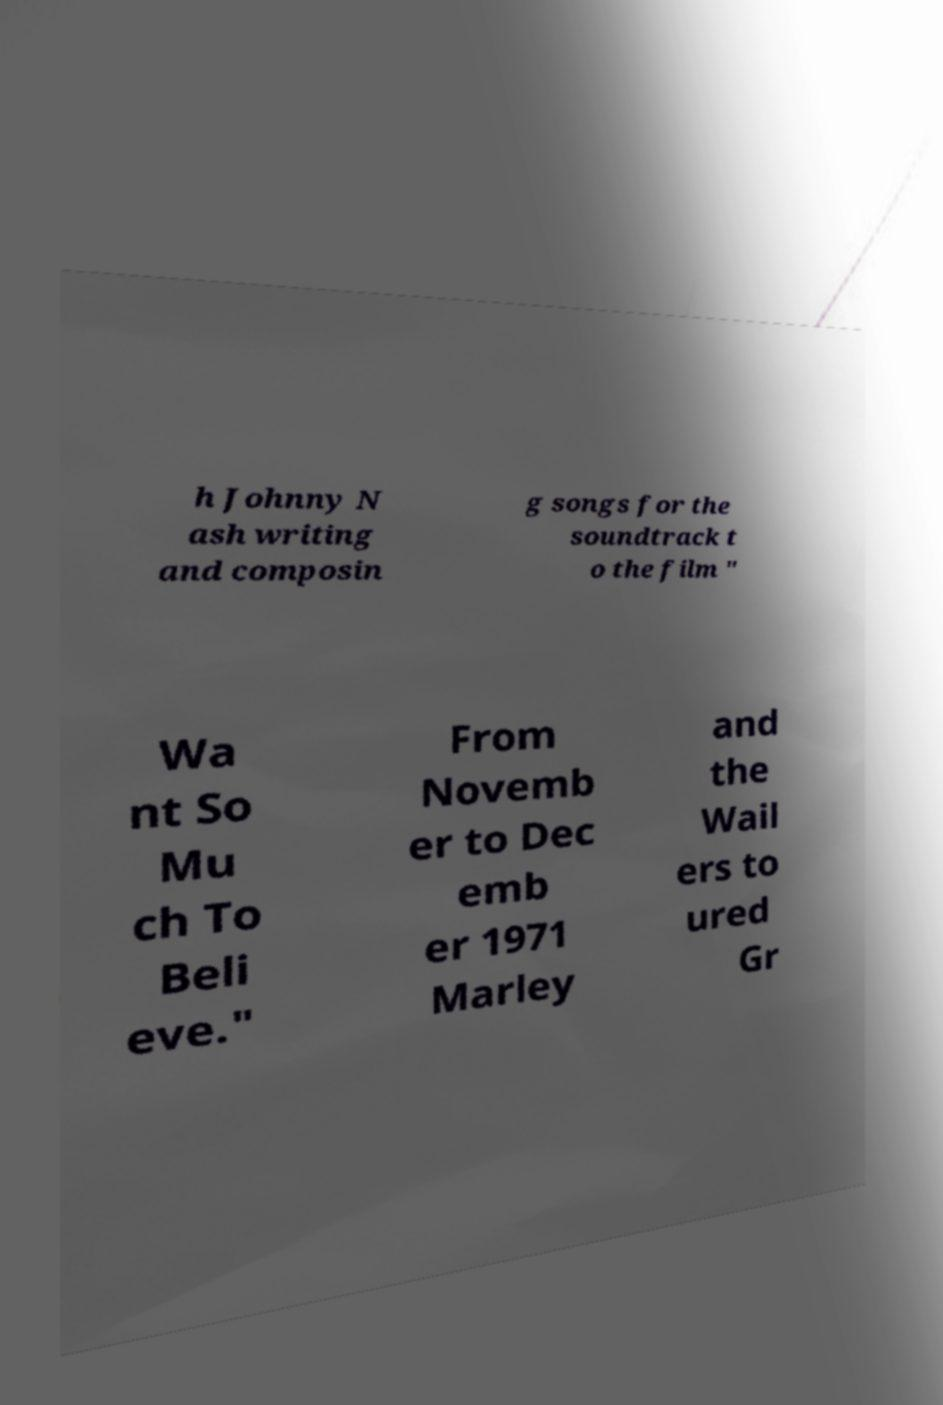Please read and relay the text visible in this image. What does it say? h Johnny N ash writing and composin g songs for the soundtrack t o the film " Wa nt So Mu ch To Beli eve." From Novemb er to Dec emb er 1971 Marley and the Wail ers to ured Gr 